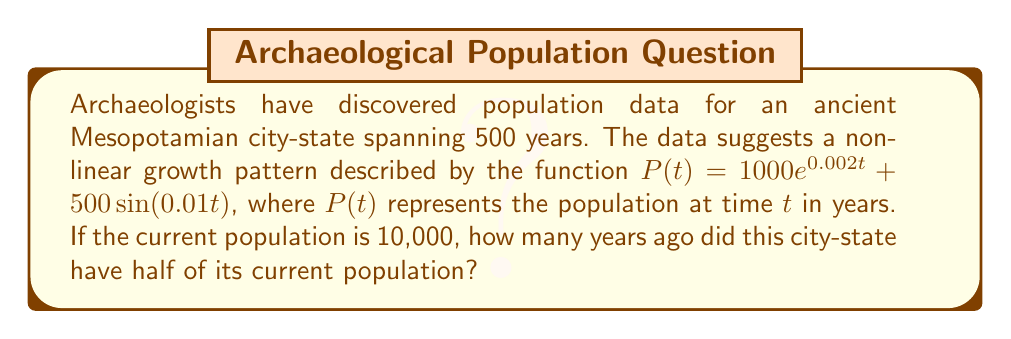Solve this math problem. Let's approach this step-by-step:

1) We need to find $t$ such that $P(t) = 5000$ (half of the current population).

2) Set up the equation:
   $$5000 = 1000e^{0.002t} + 500\sin(0.01t)$$

3) Rearrange the equation:
   $$4500 = 1000e^{0.002t} + 500\sin(0.01t)$$

4) This is a nonlinear equation that cannot be solved algebraically. We need to use numerical methods, such as Newton's method or a graphing calculator.

5) Using a numerical solver, we find that $t \approx 346.7$.

6) However, this represents the time from the starting point of our data. We need to subtract this from 500 (the total time span) to get how many years ago this population occurred.

7) Years ago = $500 - 346.7 \approx 153.3$

Therefore, the city-state had half of its current population approximately 153 years ago.
Answer: 153 years ago 